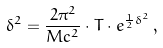Convert formula to latex. <formula><loc_0><loc_0><loc_500><loc_500>\delta ^ { 2 } = \frac { 2 \pi ^ { 2 } } { M c ^ { 2 } } \cdot T \cdot e ^ { \frac { 1 } { 2 } \delta ^ { 2 } } \, ,</formula> 